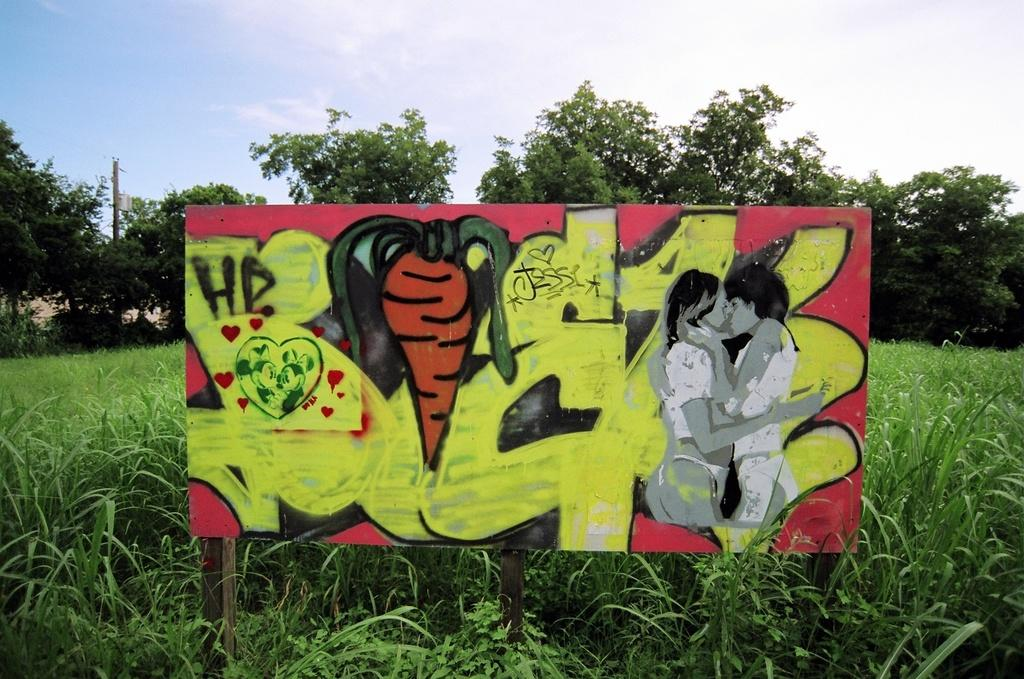What is the main structure visible in the image? There is a hoarding in the image. What type of vegetation can be seen in the image? There are plants in the image. What can be seen in the background of the image? There are trees and a pole in the background of the image. What is the condition of the sky in the image? The sky is cloudy in the image. How many trains are visible on the island in the image? There are no trains or islands present in the image. 